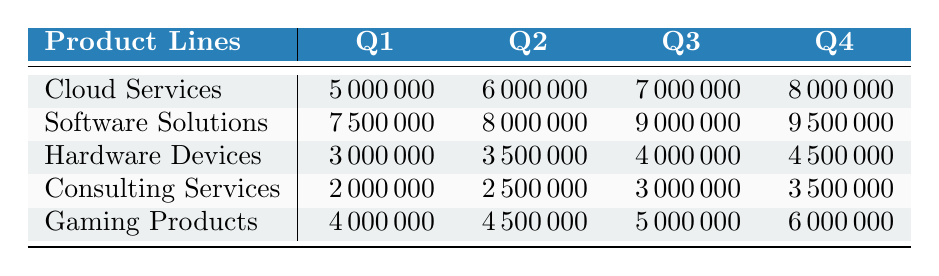What was the revenue from Cloud Services in Q3? According to the table, the revenue from Cloud Services in Q3 is explicitly listed as 7,000,000.
Answer: 7,000,000 Which product line had the highest revenue in Q2? By examining the table, we see that Software Solutions had the highest revenue in Q2 with 8,000,000.
Answer: Software Solutions What is the total revenue for Hardware Devices across all quarters? The total revenue can be calculated by adding the values for Hardware Devices in all quarters: (3,000,000 + 3,500,000 + 4,000,000 + 4,500,000) = 15,000,000.
Answer: 15,000,000 Did Consulting Services generate more revenue in Q4 than in Q3? Consulting Services generated 3,500,000 in Q4 and 3,000,000 in Q3, so yes, Q4 revenue is higher than Q3.
Answer: Yes What is the average revenue from Gaming Products over the four quarters? The average revenue can be found by summing the revenues for Gaming Products (4,000,000 + 4,500,000 + 5,000,000 + 6,000,000) = 19,500,000 and dividing by 4, which gives 4,875,000.
Answer: 4,875,000 Which product line experienced the largest increase in revenue from Q1 to Q4? The increase for each product line can be calculated: Cloud Services (3,000,000), Software Solutions (2,000,000), Hardware Devices (1,500,000), Consulting Services (1,500,000), and Gaming Products (2,000,000). The largest increase is from Cloud Services.
Answer: Cloud Services What was the total revenue generated from all product lines in Q1? By summing the revenues of all product lines in Q1: (5,000,000 + 7,500,000 + 3,000,000 + 2,000,000 + 4,000,000) = 21,500,000.
Answer: 21,500,000 Is the revenue from Software Solutions in Q4 greater than the combined revenue of Consulting Services in Q2 and Gaming Products in Q3? Software Solutions in Q4 generated 9,500,000 while Consulting Services in Q2 and Gaming Products in Q3 combined to (2,500,000 + 5,000,000) = 7,500,000, thus confirming the statement.
Answer: Yes 